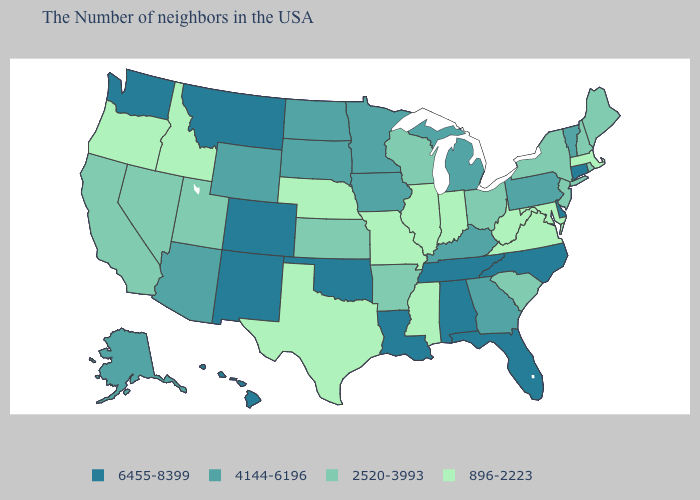Does New York have a higher value than Idaho?
Quick response, please. Yes. Name the states that have a value in the range 2520-3993?
Be succinct. Maine, Rhode Island, New Hampshire, New York, New Jersey, South Carolina, Ohio, Wisconsin, Arkansas, Kansas, Utah, Nevada, California. Does the first symbol in the legend represent the smallest category?
Write a very short answer. No. What is the value of Iowa?
Give a very brief answer. 4144-6196. Among the states that border Ohio , does Michigan have the highest value?
Quick response, please. Yes. What is the highest value in states that border Alabama?
Quick response, please. 6455-8399. What is the value of New Jersey?
Give a very brief answer. 2520-3993. What is the lowest value in the West?
Write a very short answer. 896-2223. Among the states that border Nevada , does Utah have the lowest value?
Quick response, please. No. What is the highest value in states that border Texas?
Quick response, please. 6455-8399. Which states have the lowest value in the MidWest?
Short answer required. Indiana, Illinois, Missouri, Nebraska. Name the states that have a value in the range 6455-8399?
Quick response, please. Connecticut, Delaware, North Carolina, Florida, Alabama, Tennessee, Louisiana, Oklahoma, Colorado, New Mexico, Montana, Washington, Hawaii. What is the lowest value in states that border Vermont?
Keep it brief. 896-2223. What is the value of Maine?
Write a very short answer. 2520-3993. What is the value of Washington?
Quick response, please. 6455-8399. 